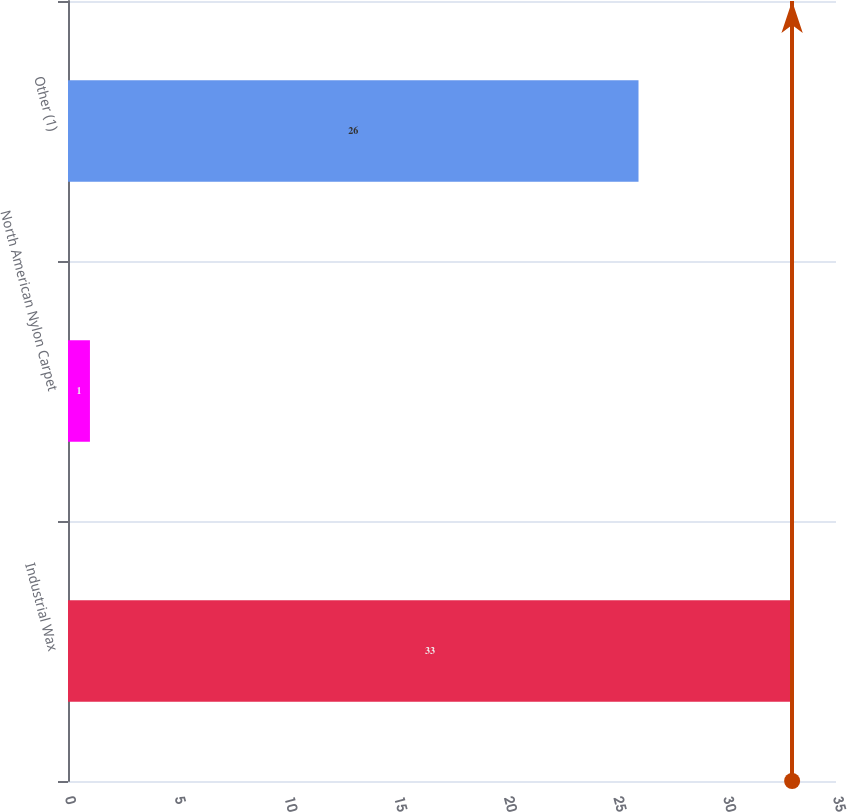Convert chart to OTSL. <chart><loc_0><loc_0><loc_500><loc_500><bar_chart><fcel>Industrial Wax<fcel>North American Nylon Carpet<fcel>Other (1)<nl><fcel>33<fcel>1<fcel>26<nl></chart> 